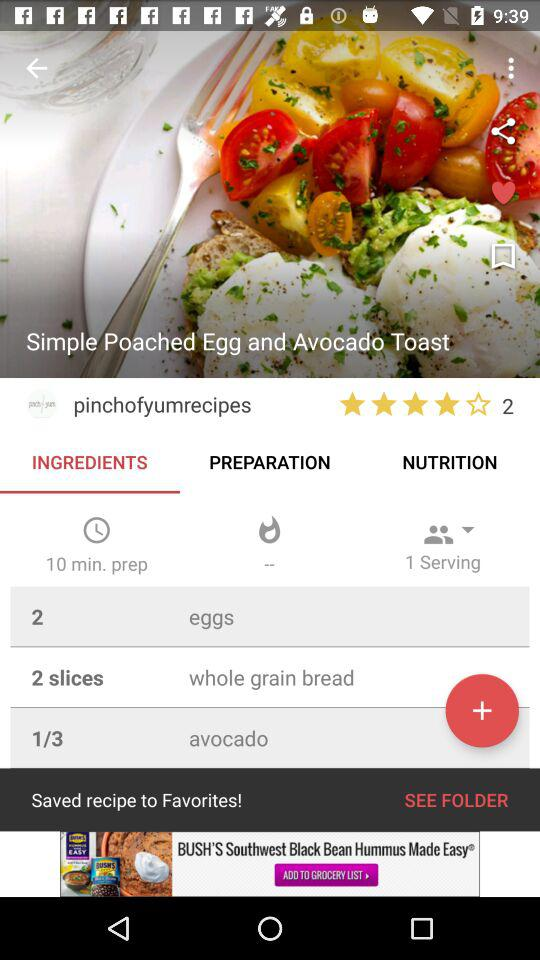What is the rating of the dish? The rating of the dish is 4 stars. 